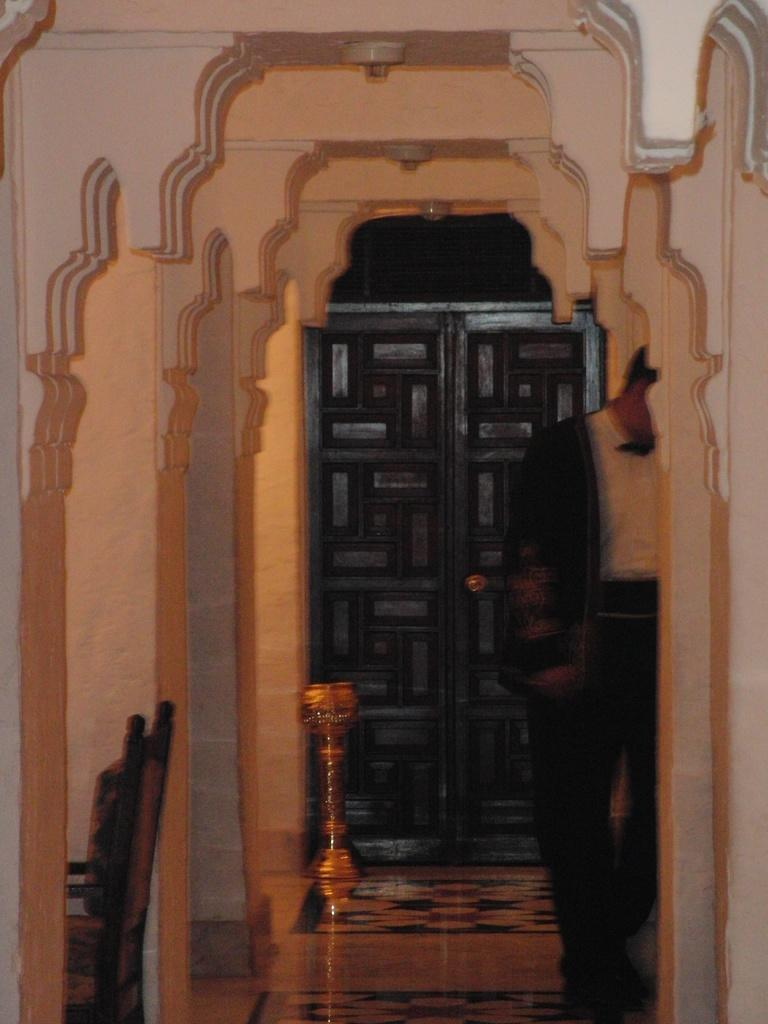What type of furniture is present in the image? There are chairs in the image. What is a possible entry or exit point in the image? There is a door in the image. What else can be found on the floor in the image? There are other objects on the floor in the image. Can you tell me who is wearing the crown in the image? There is no crown present in the image. What is the comparison between the chairs and the door in the image? The question is not relevant to the image, as it does not involve any comparison between the chairs and the door. 